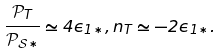Convert formula to latex. <formula><loc_0><loc_0><loc_500><loc_500>\frac { \mathcal { P } _ { T } } { \mathcal { P } _ { \mathcal { S } \ast } } \simeq 4 \epsilon _ { 1 \ast } , n _ { T } \simeq - 2 \epsilon _ { 1 \ast } .</formula> 